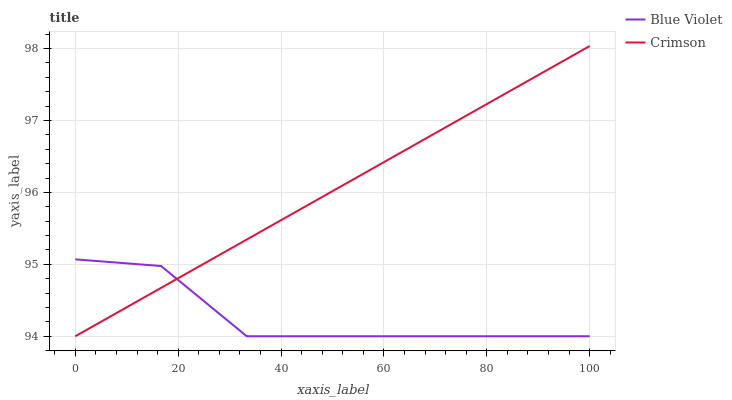Does Blue Violet have the maximum area under the curve?
Answer yes or no. No. Is Blue Violet the smoothest?
Answer yes or no. No. Does Blue Violet have the highest value?
Answer yes or no. No. 